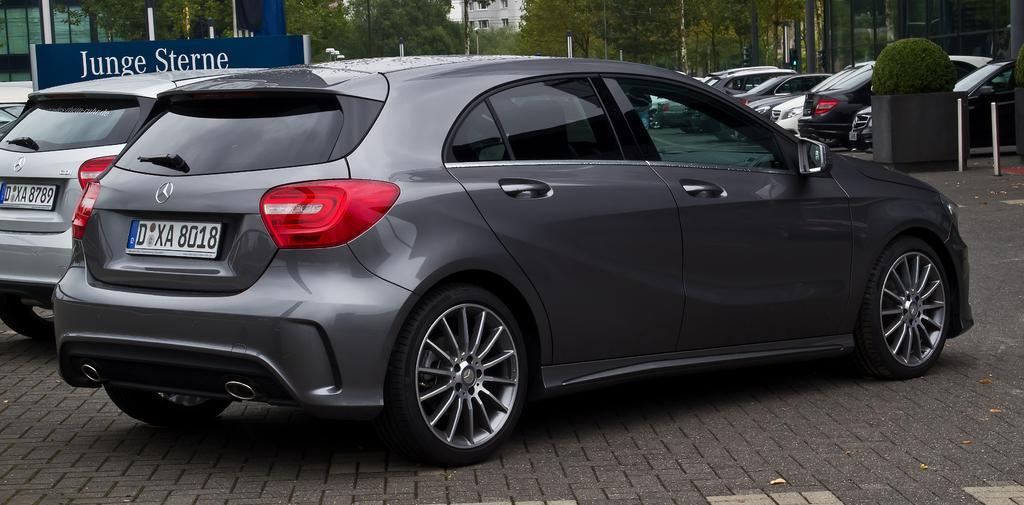How would you summarize this image in a sentence or two? In this image we can see cars on the road. In the background of the image there are trees, clouds. There is a board with some text on it. 